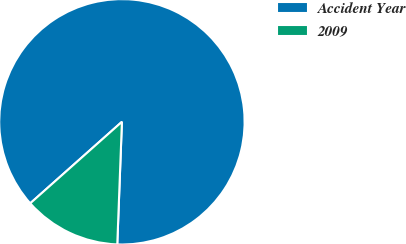<chart> <loc_0><loc_0><loc_500><loc_500><pie_chart><fcel>Accident Year<fcel>2009<nl><fcel>87.17%<fcel>12.83%<nl></chart> 